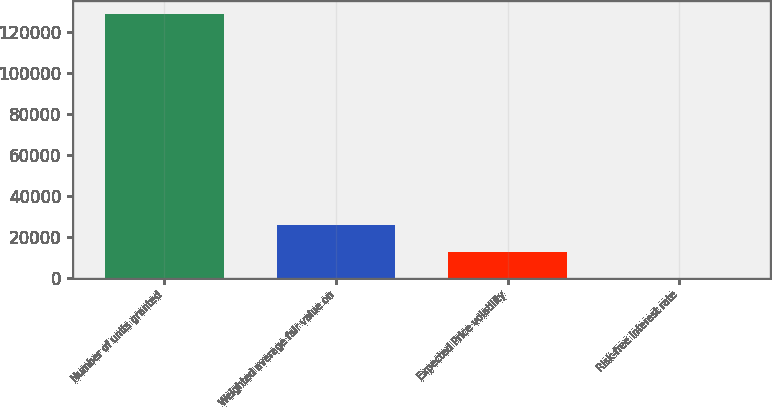<chart> <loc_0><loc_0><loc_500><loc_500><bar_chart><fcel>Number of units granted<fcel>Weighted average fair value on<fcel>Expected Price volatility<fcel>Risk-free interest rate<nl><fcel>129150<fcel>25830.5<fcel>12915.6<fcel>0.63<nl></chart> 